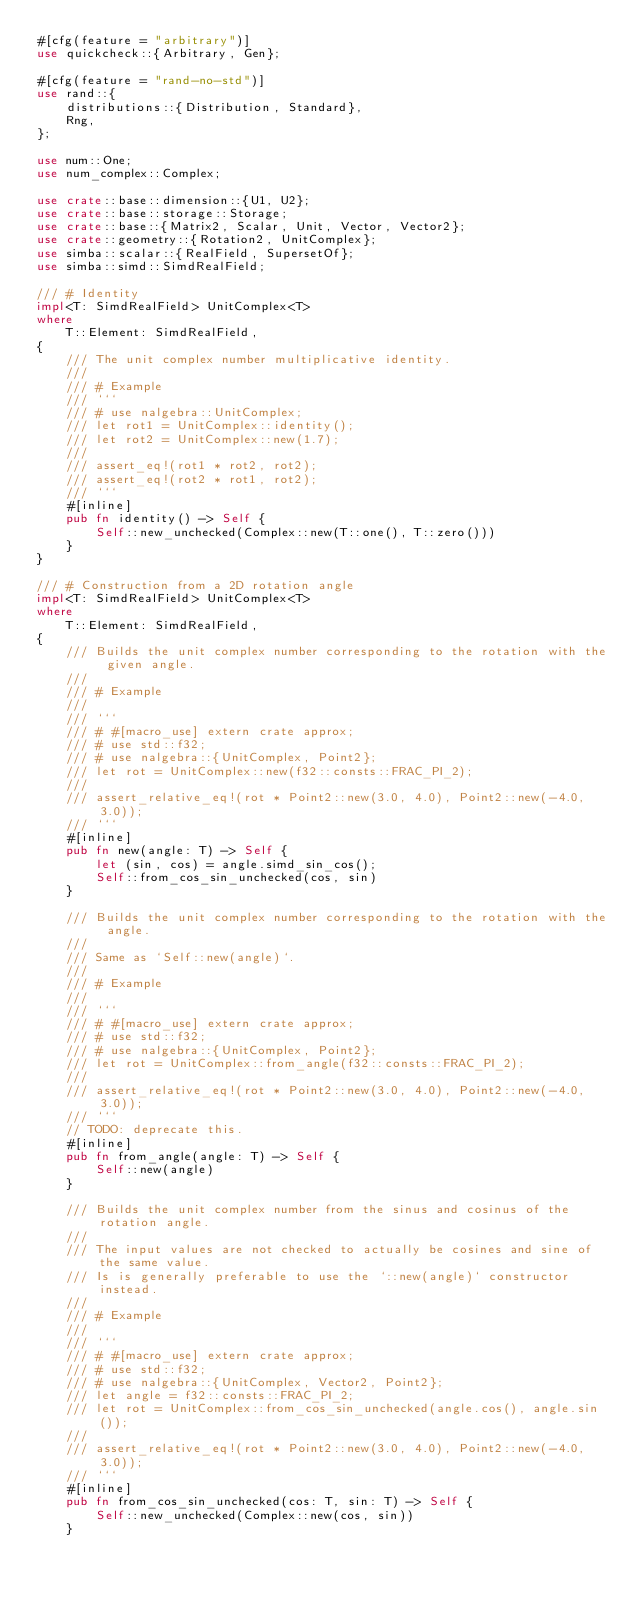<code> <loc_0><loc_0><loc_500><loc_500><_Rust_>#[cfg(feature = "arbitrary")]
use quickcheck::{Arbitrary, Gen};

#[cfg(feature = "rand-no-std")]
use rand::{
    distributions::{Distribution, Standard},
    Rng,
};

use num::One;
use num_complex::Complex;

use crate::base::dimension::{U1, U2};
use crate::base::storage::Storage;
use crate::base::{Matrix2, Scalar, Unit, Vector, Vector2};
use crate::geometry::{Rotation2, UnitComplex};
use simba::scalar::{RealField, SupersetOf};
use simba::simd::SimdRealField;

/// # Identity
impl<T: SimdRealField> UnitComplex<T>
where
    T::Element: SimdRealField,
{
    /// The unit complex number multiplicative identity.
    ///
    /// # Example
    /// ```
    /// # use nalgebra::UnitComplex;
    /// let rot1 = UnitComplex::identity();
    /// let rot2 = UnitComplex::new(1.7);
    ///
    /// assert_eq!(rot1 * rot2, rot2);
    /// assert_eq!(rot2 * rot1, rot2);
    /// ```
    #[inline]
    pub fn identity() -> Self {
        Self::new_unchecked(Complex::new(T::one(), T::zero()))
    }
}

/// # Construction from a 2D rotation angle
impl<T: SimdRealField> UnitComplex<T>
where
    T::Element: SimdRealField,
{
    /// Builds the unit complex number corresponding to the rotation with the given angle.
    ///
    /// # Example
    ///
    /// ```
    /// # #[macro_use] extern crate approx;
    /// # use std::f32;
    /// # use nalgebra::{UnitComplex, Point2};
    /// let rot = UnitComplex::new(f32::consts::FRAC_PI_2);
    ///
    /// assert_relative_eq!(rot * Point2::new(3.0, 4.0), Point2::new(-4.0, 3.0));
    /// ```
    #[inline]
    pub fn new(angle: T) -> Self {
        let (sin, cos) = angle.simd_sin_cos();
        Self::from_cos_sin_unchecked(cos, sin)
    }

    /// Builds the unit complex number corresponding to the rotation with the angle.
    ///
    /// Same as `Self::new(angle)`.
    ///
    /// # Example
    ///
    /// ```
    /// # #[macro_use] extern crate approx;
    /// # use std::f32;
    /// # use nalgebra::{UnitComplex, Point2};
    /// let rot = UnitComplex::from_angle(f32::consts::FRAC_PI_2);
    ///
    /// assert_relative_eq!(rot * Point2::new(3.0, 4.0), Point2::new(-4.0, 3.0));
    /// ```
    // TODO: deprecate this.
    #[inline]
    pub fn from_angle(angle: T) -> Self {
        Self::new(angle)
    }

    /// Builds the unit complex number from the sinus and cosinus of the rotation angle.
    ///
    /// The input values are not checked to actually be cosines and sine of the same value.
    /// Is is generally preferable to use the `::new(angle)` constructor instead.
    ///
    /// # Example
    ///
    /// ```
    /// # #[macro_use] extern crate approx;
    /// # use std::f32;
    /// # use nalgebra::{UnitComplex, Vector2, Point2};
    /// let angle = f32::consts::FRAC_PI_2;
    /// let rot = UnitComplex::from_cos_sin_unchecked(angle.cos(), angle.sin());
    ///
    /// assert_relative_eq!(rot * Point2::new(3.0, 4.0), Point2::new(-4.0, 3.0));
    /// ```
    #[inline]
    pub fn from_cos_sin_unchecked(cos: T, sin: T) -> Self {
        Self::new_unchecked(Complex::new(cos, sin))
    }
</code> 